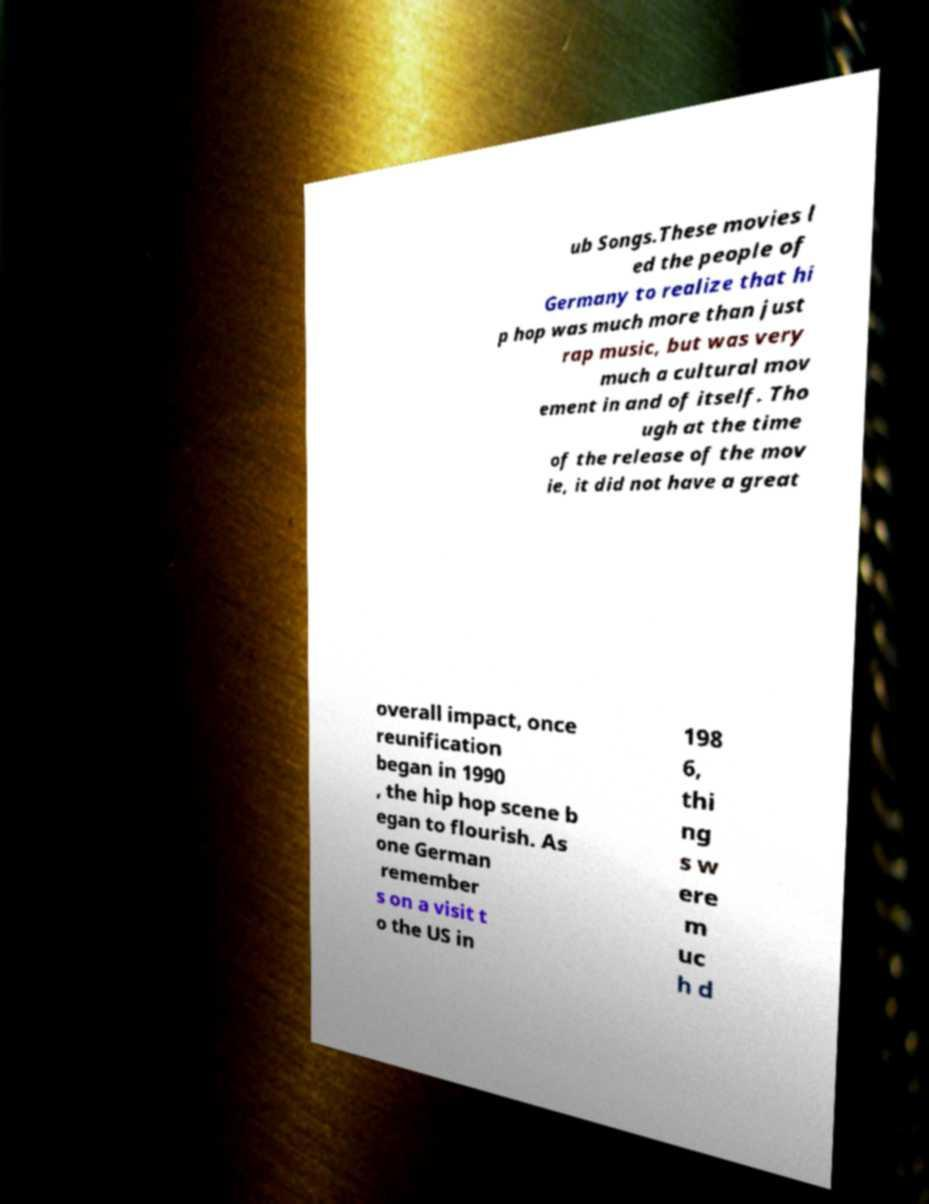What messages or text are displayed in this image? I need them in a readable, typed format. ub Songs.These movies l ed the people of Germany to realize that hi p hop was much more than just rap music, but was very much a cultural mov ement in and of itself. Tho ugh at the time of the release of the mov ie, it did not have a great overall impact, once reunification began in 1990 , the hip hop scene b egan to flourish. As one German remember s on a visit t o the US in 198 6, thi ng s w ere m uc h d 